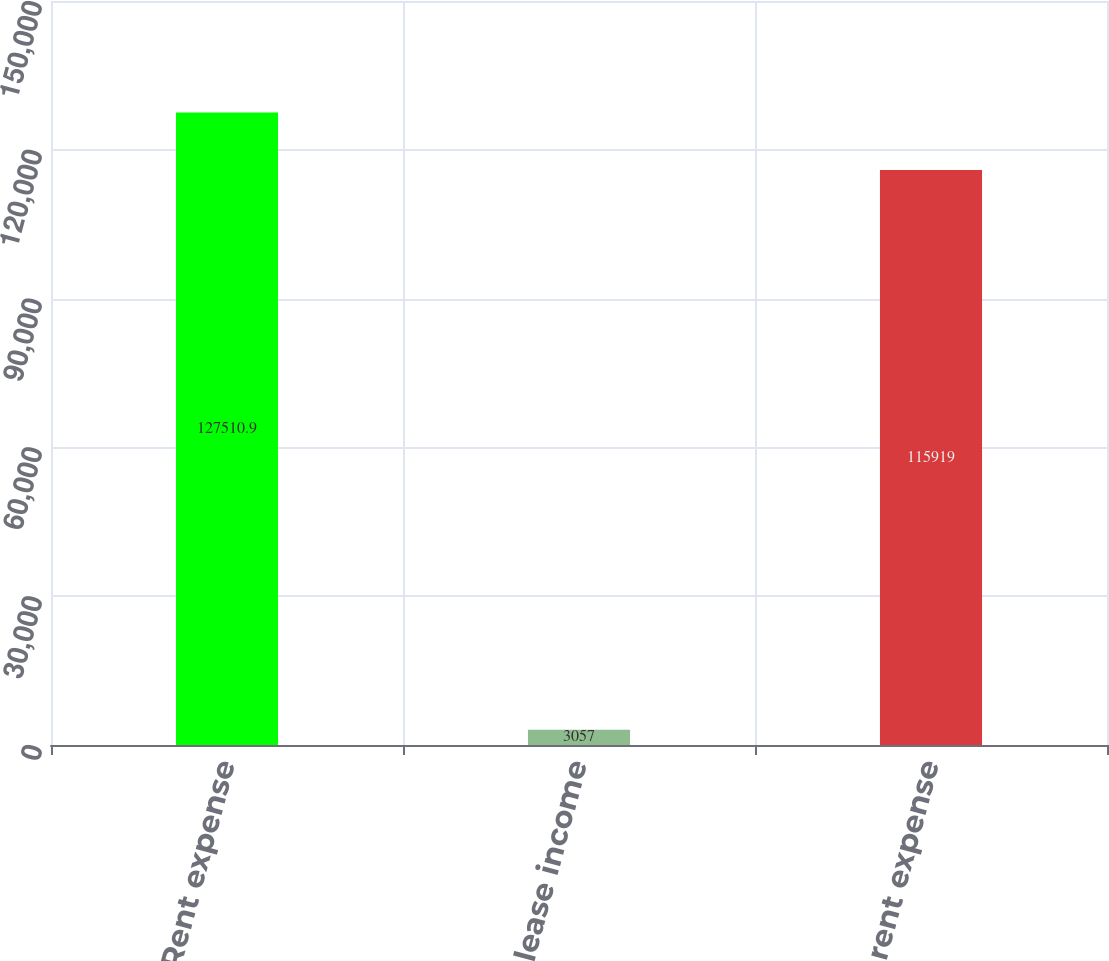<chart> <loc_0><loc_0><loc_500><loc_500><bar_chart><fcel>Rent expense<fcel>Less sublease income<fcel>Net rent expense<nl><fcel>127511<fcel>3057<fcel>115919<nl></chart> 